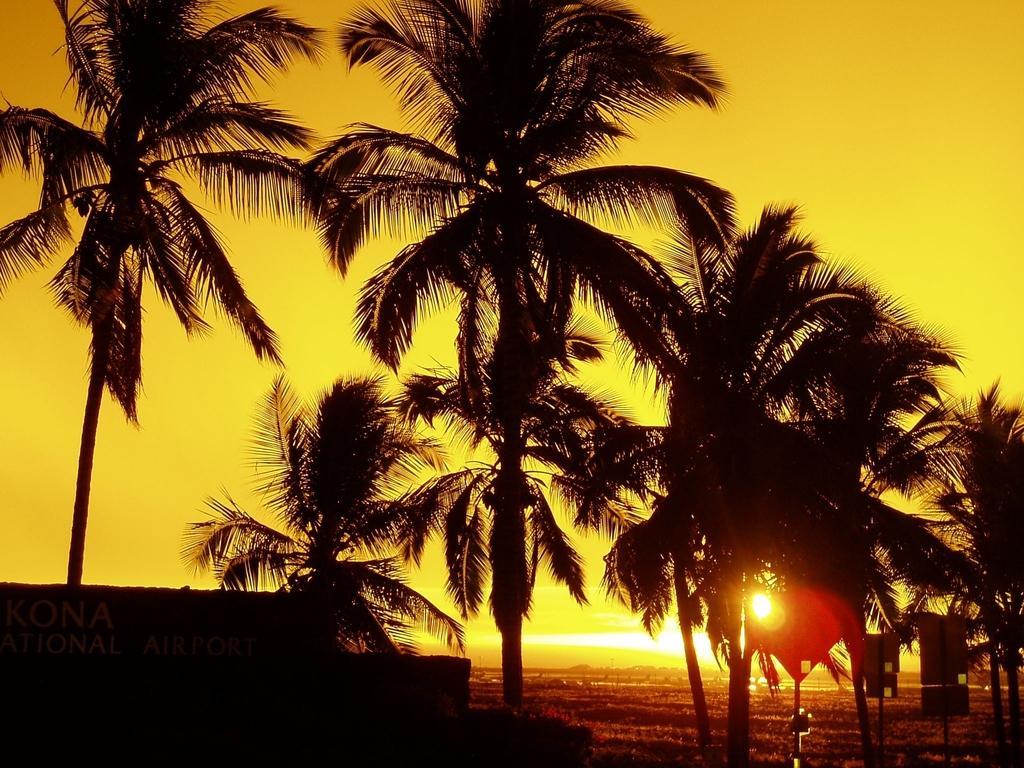Can you describe this image briefly? There are many coconut trees and there is a sunrise clearly visible through the one of tree. 